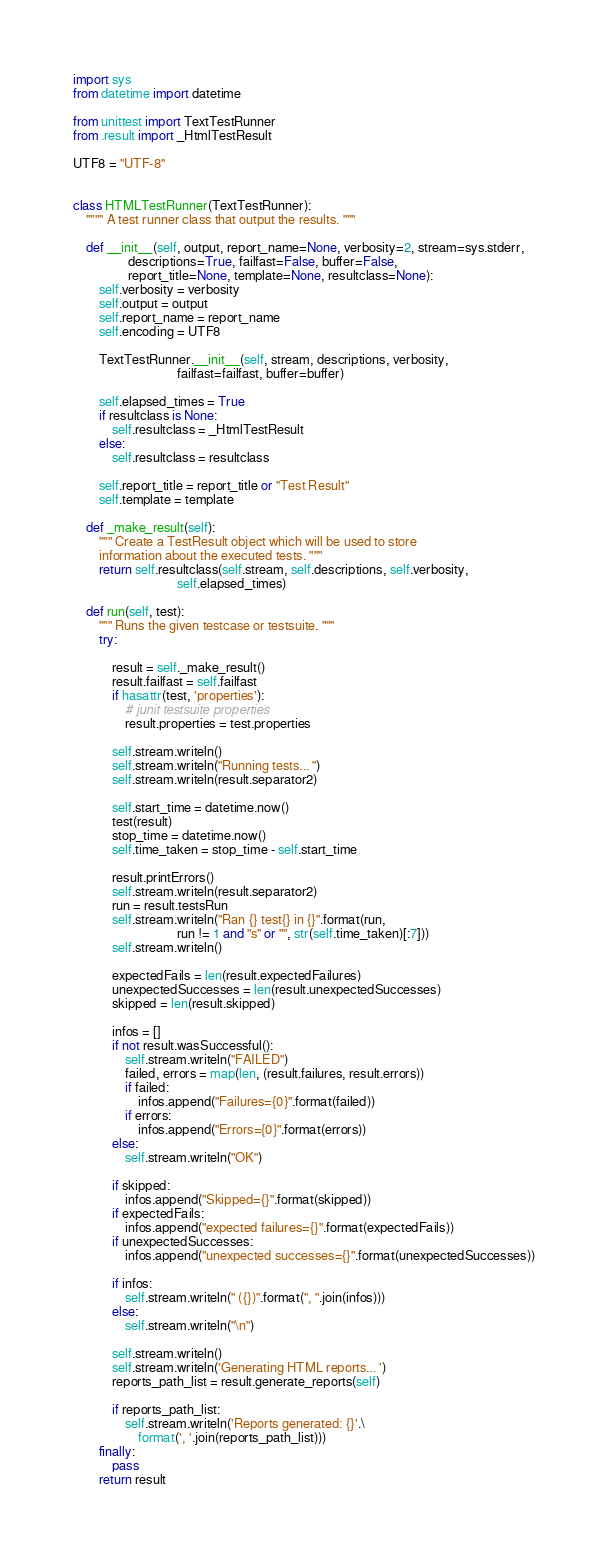<code> <loc_0><loc_0><loc_500><loc_500><_Python_>import sys
from datetime import datetime

from unittest import TextTestRunner
from .result import _HtmlTestResult

UTF8 = "UTF-8"


class HTMLTestRunner(TextTestRunner):
    """" A test runner class that output the results. """

    def __init__(self, output, report_name=None, verbosity=2, stream=sys.stderr,
                 descriptions=True, failfast=False, buffer=False,
                 report_title=None, template=None, resultclass=None):
        self.verbosity = verbosity
        self.output = output
        self.report_name = report_name
        self.encoding = UTF8

        TextTestRunner.__init__(self, stream, descriptions, verbosity,
                                failfast=failfast, buffer=buffer)

        self.elapsed_times = True
        if resultclass is None:
            self.resultclass = _HtmlTestResult
        else:
            self.resultclass = resultclass

        self.report_title = report_title or "Test Result"
        self.template = template

    def _make_result(self):
        """ Create a TestResult object which will be used to store
        information about the executed tests. """
        return self.resultclass(self.stream, self.descriptions, self.verbosity,
                                self.elapsed_times)

    def run(self, test):
        """ Runs the given testcase or testsuite. """
        try:

            result = self._make_result()
            result.failfast = self.failfast
            if hasattr(test, 'properties'):
                # junit testsuite properties
                result.properties = test.properties

            self.stream.writeln()
            self.stream.writeln("Running tests... ")
            self.stream.writeln(result.separator2)

            self.start_time = datetime.now()
            test(result)
            stop_time = datetime.now()
            self.time_taken = stop_time - self.start_time

            result.printErrors()
            self.stream.writeln(result.separator2)
            run = result.testsRun
            self.stream.writeln("Ran {} test{} in {}".format(run,
                                run != 1 and "s" or "", str(self.time_taken)[:7]))
            self.stream.writeln()

            expectedFails = len(result.expectedFailures)
            unexpectedSuccesses = len(result.unexpectedSuccesses)
            skipped = len(result.skipped)

            infos = []
            if not result.wasSuccessful():
                self.stream.writeln("FAILED")
                failed, errors = map(len, (result.failures, result.errors))
                if failed:
                    infos.append("Failures={0}".format(failed))
                if errors:
                    infos.append("Errors={0}".format(errors))
            else:
                self.stream.writeln("OK")

            if skipped:
                infos.append("Skipped={}".format(skipped))
            if expectedFails:
                infos.append("expected failures={}".format(expectedFails))
            if unexpectedSuccesses:
                infos.append("unexpected successes={}".format(unexpectedSuccesses))

            if infos:
                self.stream.writeln(" ({})".format(", ".join(infos)))
            else:
                self.stream.writeln("\n")

            self.stream.writeln()
            self.stream.writeln('Generating HTML reports... ')
            reports_path_list = result.generate_reports(self)

            if reports_path_list:
                self.stream.writeln('Reports generated: {}'.\
                    format(', '.join(reports_path_list)))
        finally:
            pass
        return result
</code> 